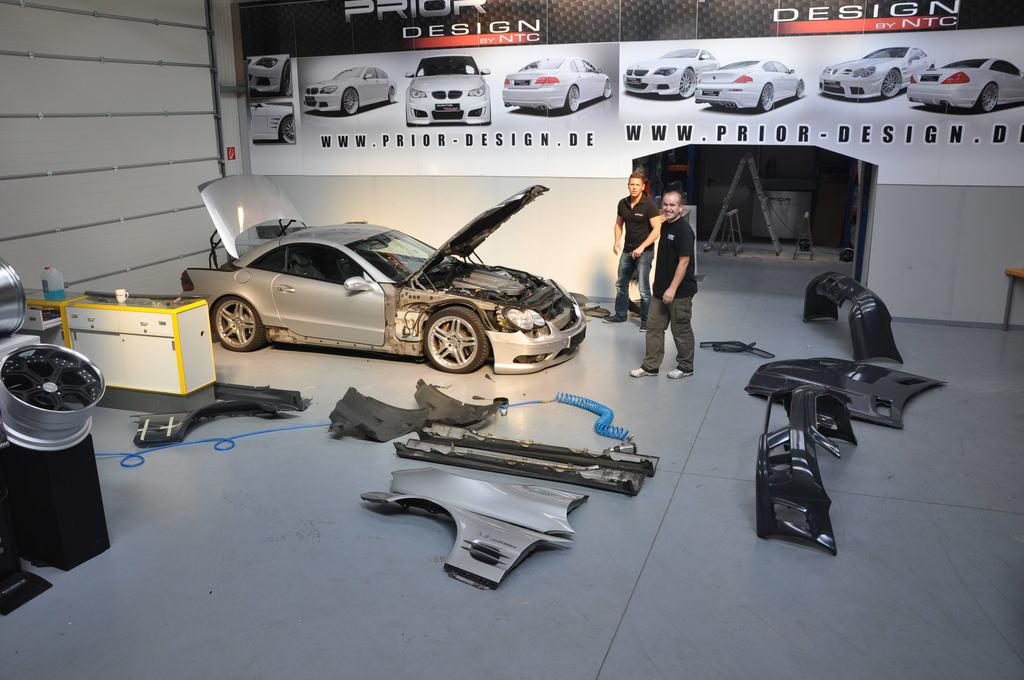What is the main subject of the image? There is a car in the image. What is the condition of the car in the image? Some parts of the car are on the floor. Are there any people in the image? Yes, there are two men standing in the image. What is on the wall in the image? There is a poster on the wall. What is depicted on the poster? The poster contains images of cars. What type of chalk is being used by the parent in the image? There is no chalk or parent present in the image. What fact is being discussed by the two men in the image? The image does not provide any information about a fact being discussed by the two men. 